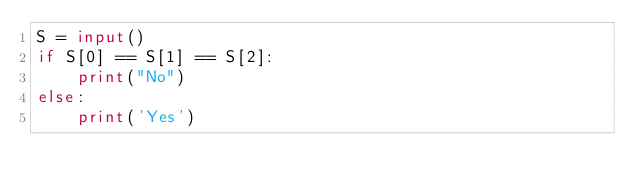<code> <loc_0><loc_0><loc_500><loc_500><_Python_>S = input()
if S[0] == S[1] == S[2]:
    print("No")
else:
    print('Yes')
</code> 